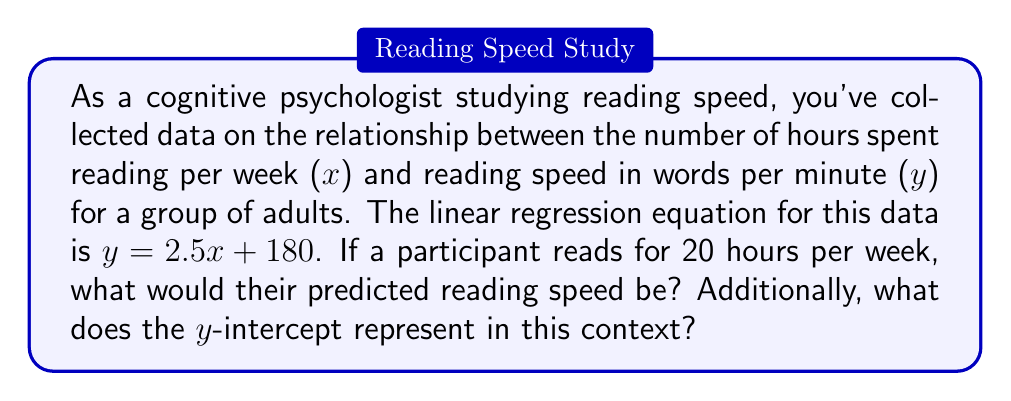Show me your answer to this math problem. To solve this problem, we'll follow these steps:

1. Understand the given linear regression equation:
   $y = 2.5x + 180$
   Where:
   $y$ = reading speed in words per minute
   $x$ = number of hours spent reading per week
   2.5 = slope (increase in reading speed per hour of reading)
   180 = y-intercept

2. Calculate the predicted reading speed for 20 hours of reading per week:
   $x = 20$
   $y = 2.5(20) + 180$
   $y = 50 + 180$
   $y = 230$

3. Interpret the y-intercept:
   The y-intercept (180) represents the predicted reading speed for someone who spends 0 hours reading per week. In this context, it can be interpreted as the baseline reading speed for adults in the study, assuming no additional reading practice.
Answer: 230 words per minute; baseline reading speed with no extra practice 